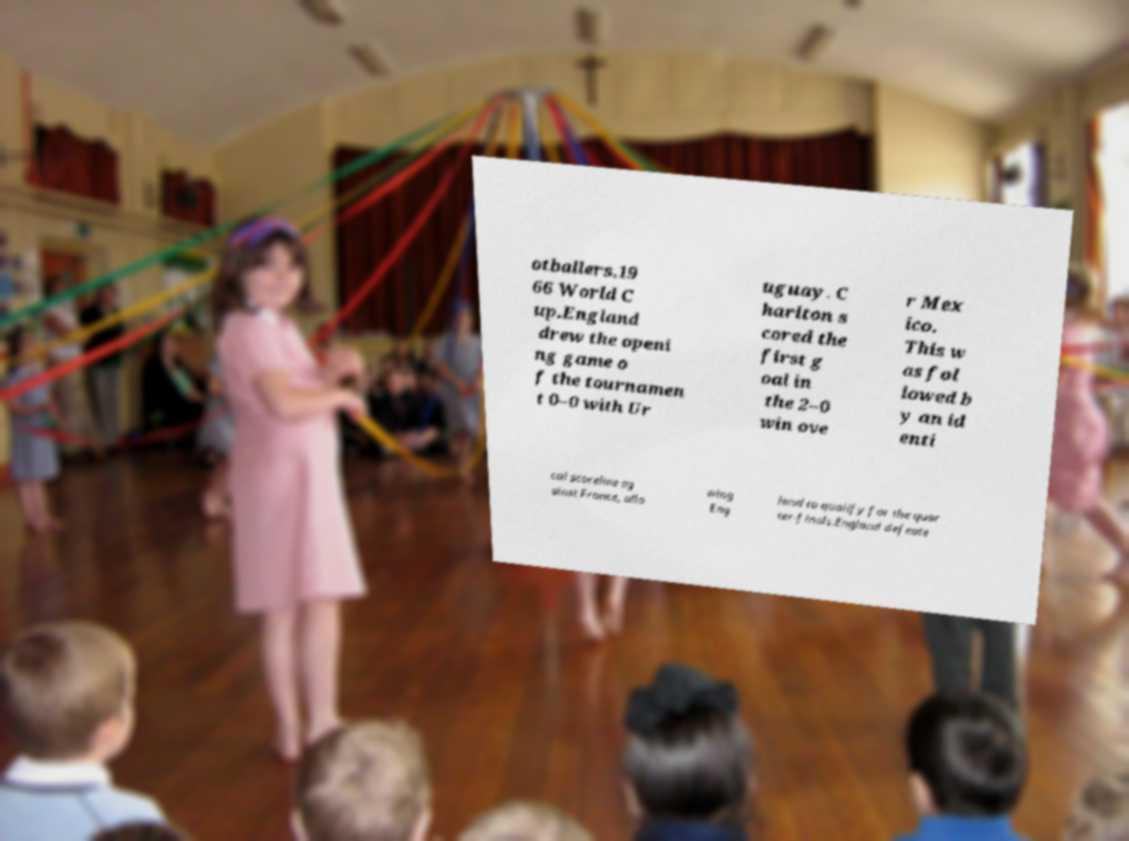For documentation purposes, I need the text within this image transcribed. Could you provide that? otballers.19 66 World C up.England drew the openi ng game o f the tournamen t 0–0 with Ur uguay. C harlton s cored the first g oal in the 2–0 win ove r Mex ico. This w as fol lowed b y an id enti cal scoreline ag ainst France, allo wing Eng land to qualify for the quar ter-finals.England defeate 